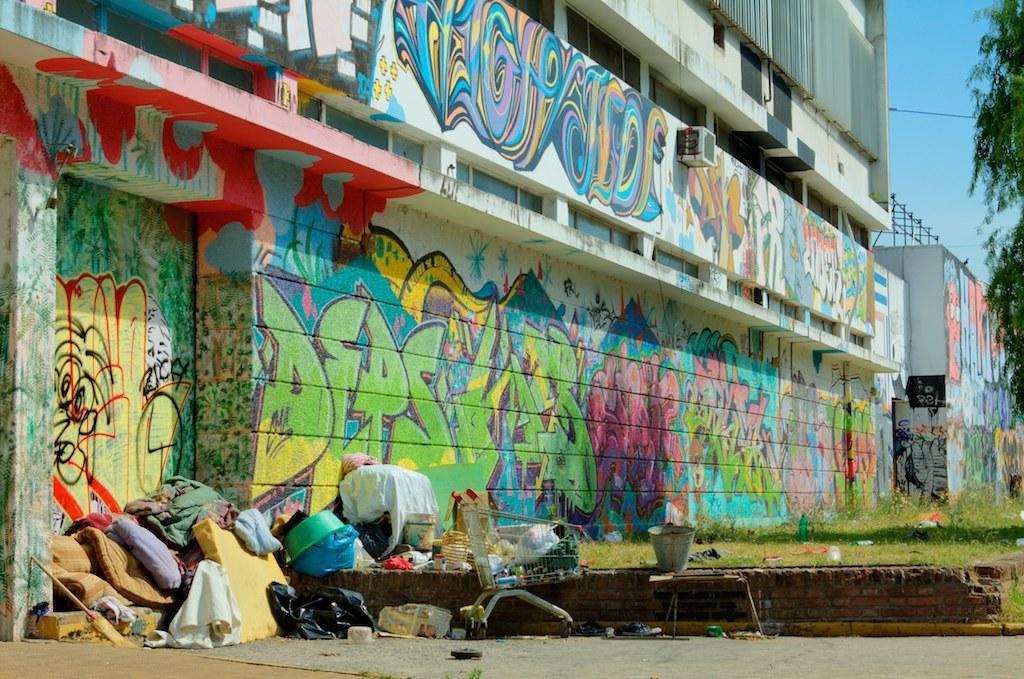Can you describe this image briefly? In the picture I can see the building. I can see an air conditioner on the wall of the building. I can see the graffiti on the wall. There is a tree on the right side. I can see the mattress, a wooden stick, plastic covers, luggage trolley and metal bucket. 